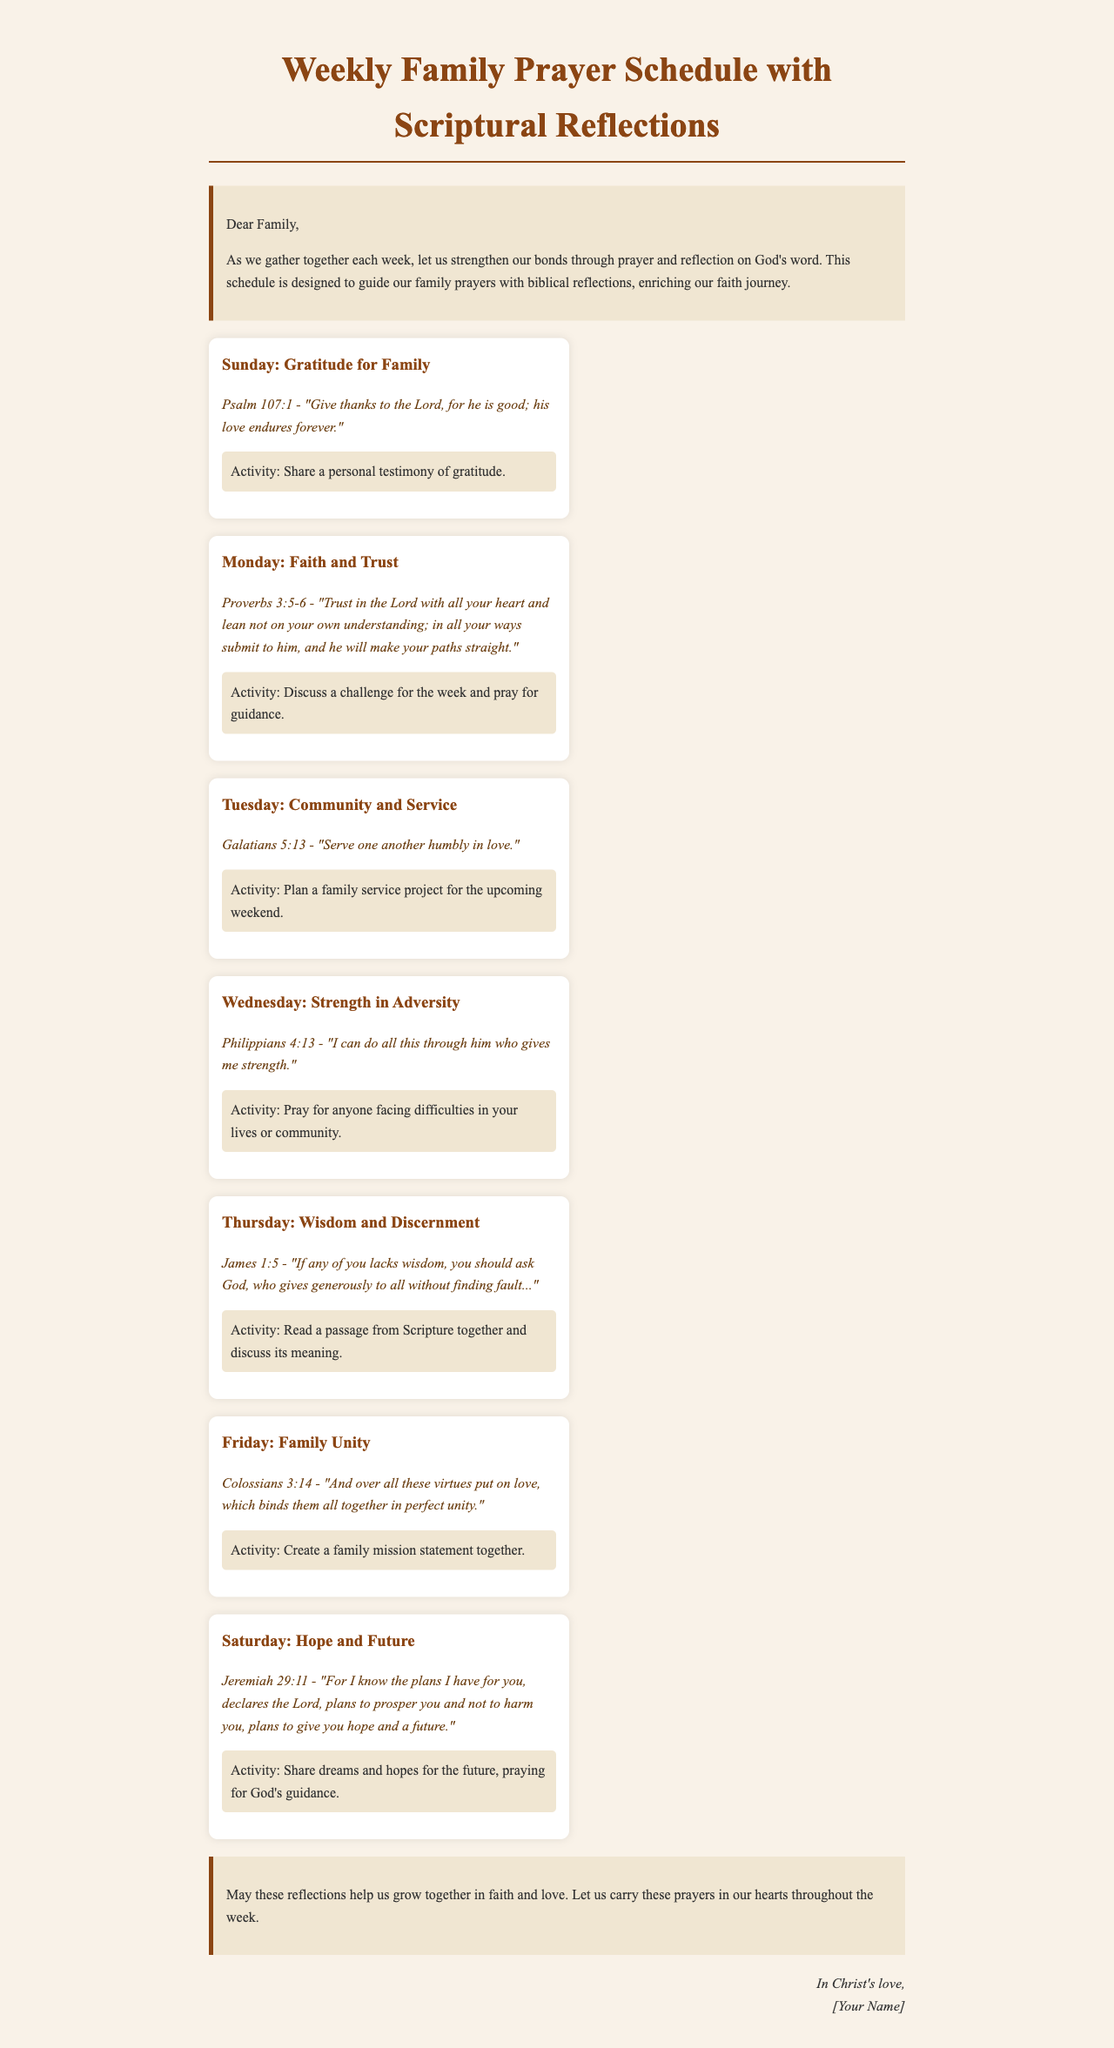What is the title of the document? The title is prominently displayed at the top of the document.
Answer: Weekly Family Prayer Schedule with Scriptural Reflections What day focuses on gratitude for family? The days are listed with their corresponding themes.
Answer: Sunday Which scripture is associated with trust? The reflections provide specific scriptures for each day's theme.
Answer: Proverbs 3:5-6 What activity is planned for Wednesday? Activities are detailed under each day's theme.
Answer: Pray for anyone facing difficulties in your lives or community What is the theme for Tuesday? Themes are clearly stated in the headers of each section.
Answer: Community and Service How many days are included in the prayer schedule? The document lists a schedule for each day of the week.
Answer: Seven What passage is referenced for hope and future? Bible passages are provided with each day's theme.
Answer: Jeremiah 29:11 Who is the document signed by? The signature is located at the end of the document.
Answer: [Your Name] 